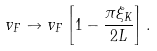Convert formula to latex. <formula><loc_0><loc_0><loc_500><loc_500>v _ { F } \to v _ { F } \left [ 1 - \frac { \pi \xi _ { K } } { 2 L } \right ] .</formula> 